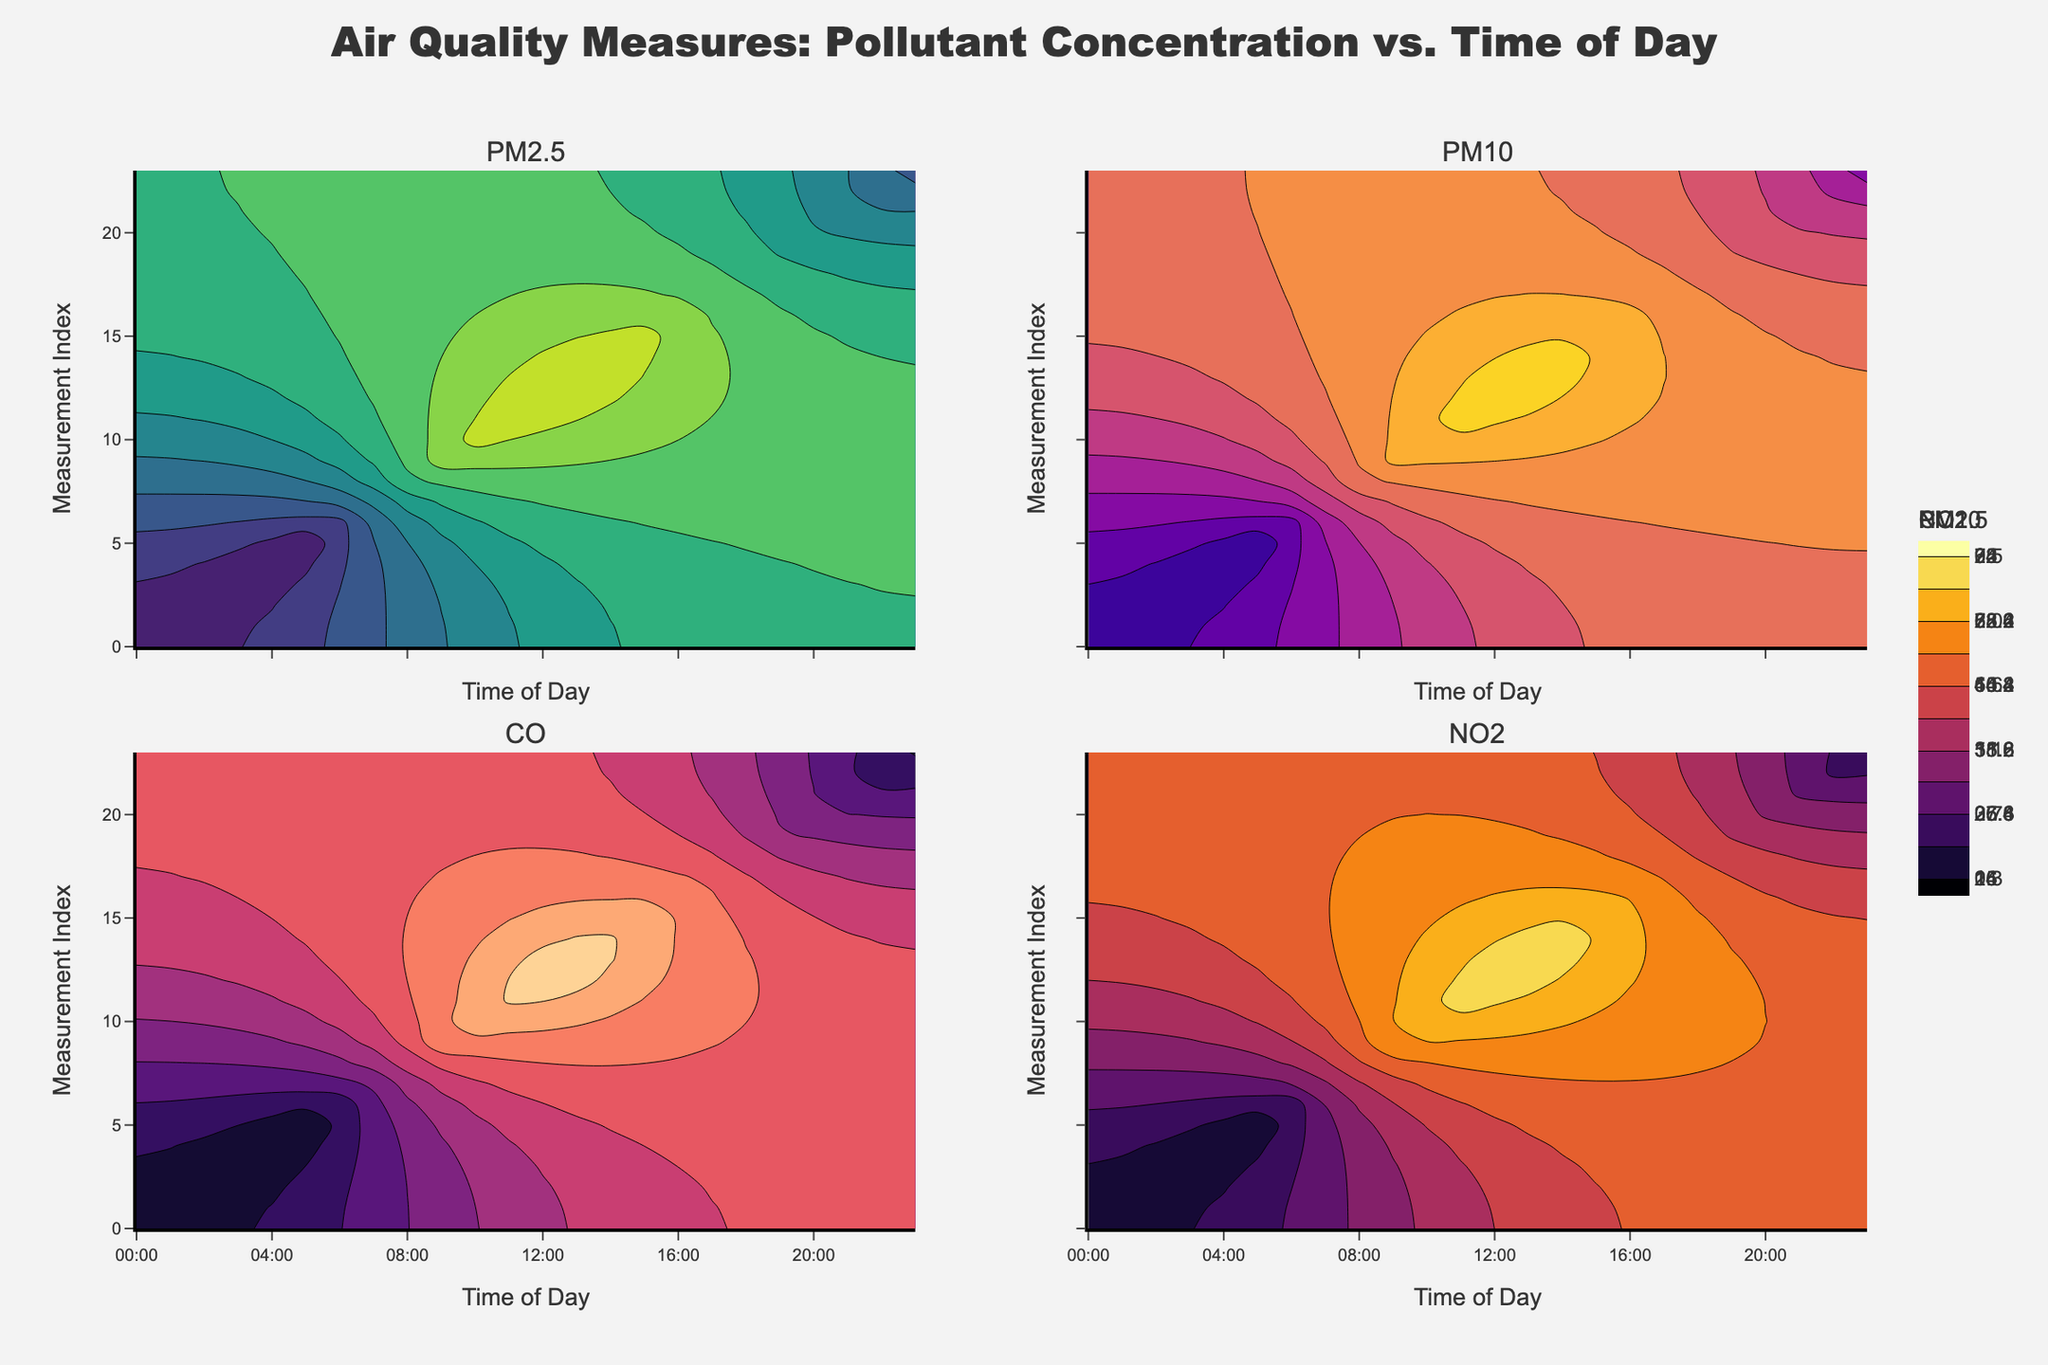What is the title of the figure? The title is found at the top of the figure and provides an overview of the data being visualized. In this case, it describes the relationship between pollutant concentration and time of day.
Answer: Air Quality Measures: Pollutant Concentration vs. Time of Day What is the maximum concentration of PM2.5 throughout the day? The maximum concentration of PM2.5 can be found by looking at the contour plot labeled "PM2.5" and identifying the highest value on the color scale or the highest contour line.
Answer: 74 Which pollutant shows a peak concentration at 08:00? Find the peak concentrations for each of the pollutants at 08:00 by observing the contour plots for PM2.5, PM10, CO, and NO2 near that time.
Answer: PM2.5 How does the concentration of NO2 change between 06:00 and 10:00? Look at the NO2 contour plot to observe the changes between 06:00 and 10:00, noting whether it increases, decreases, or stays the same.
Answer: Increases Which pollutant has the smallest range of concentration values throughout the day? Compare the range of concentrations (difference between maximum and minimum values) across all four pollutants by looking at their respective color scales and contour lines.
Answer: CO At what time of day does CO concentration reach its maximum? Find the highest concentration value for CO in its contour plot and note the corresponding time of day on the x-axis.
Answer: 13:00 How does the concentration of PM10 compare between 00:00 and 12:00? Compare the values of PM10 at these two times by observing the "PM10" contour plot and identifying the concentration levels at 00:00 and 12:00.
Answer: Higher at 12:00 What trend is observed in O3 concentration from morning to afternoon? Track the changes in O3 concentration from morning to afternoon by observing its values at different times and noting any increasing or decreasing trend.
Answer: Increases Which pollutant shows the most significant increase in concentration during the early morning hours? Compare the contour plots for each pollutant to identify which one has the steepest increase from 00:00 to around 06:00.
Answer: PM2.5 What happens to the concentration of NO2 after 18:00? Observe the NO2 contour plot after 18:00 to see if the concentration rises, falls, or stays consistent.
Answer: Decreases 